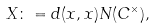Convert formula to latex. <formula><loc_0><loc_0><loc_500><loc_500>X \colon = d ( x , x ) N ( C ^ { \times } ) ,</formula> 